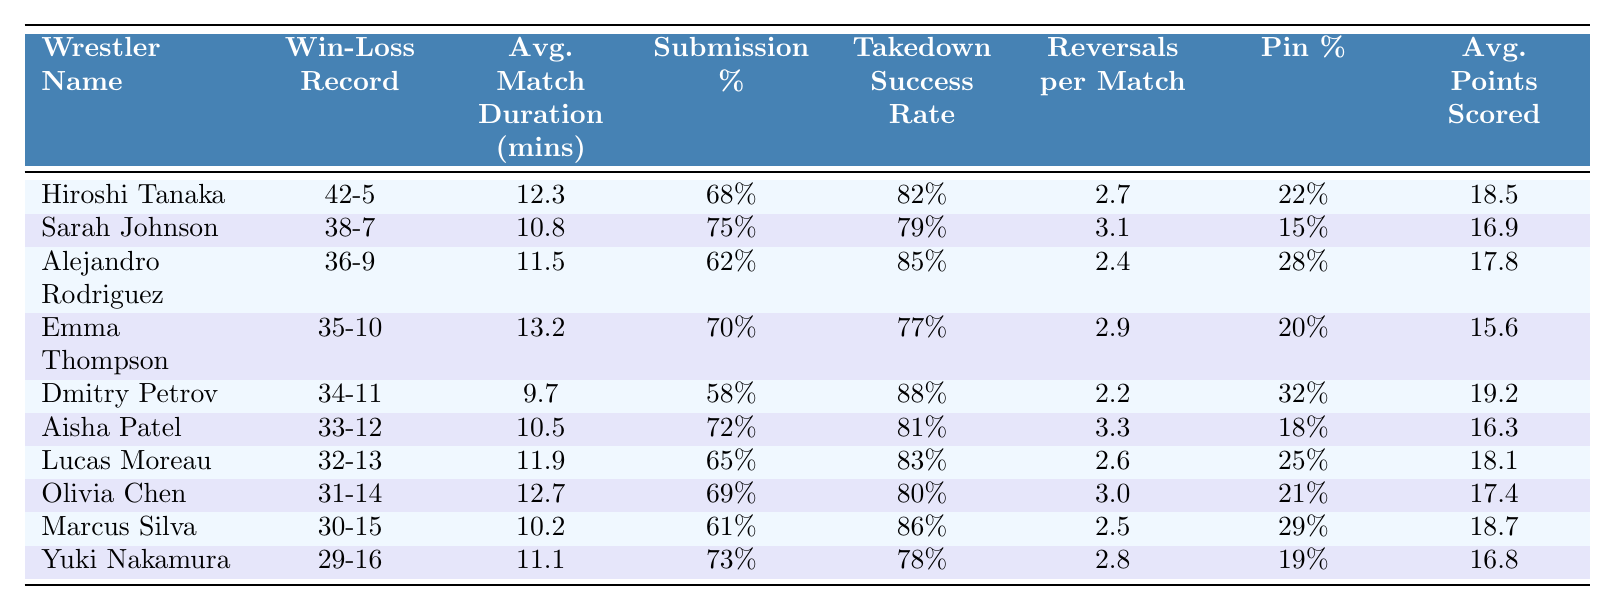What is the win-loss record of Hiroshi Tanaka? The table shows that Hiroshi Tanaka has a win-loss record listed directly under his name, which is 42-5.
Answer: 42-5 Which wrestler has the highest submission percentage? By comparing the submission percentages in the table, Sarah Johnson has the highest percentage at 75%.
Answer: 75% What is the average match duration for Emma Thompson? Looking directly in the table, the average match duration for Emma Thompson is noted as 13.2 minutes.
Answer: 13.2 minutes Who has the lowest pin percentage among the wrestlers? The pin percentages for each wrestler are listed, with Dmitry Petrov having the lowest at 58%.
Answer: 58% How many wrestlers have an average points scored greater than 17? By going through the average points scored column, we can see that six wrestlers (Hiroshi Tanaka, Alejandro Rodriguez, Dmitry Petrov, Lucas Moreau, Marcus Silva) scored more than 17 points.
Answer: 6 What is the difference in takedown success rate between Dimitry Petrov and Alejandro Rodriguez? The takedown success rate for Dimitry Petrov is 88% and for Alejandro Rodriguez is 85%. The difference is (88 - 85) = 3%.
Answer: 3% True or False: Marcus Silva has a higher takedown success rate than Yuki Nakamura. By comparing the takedown success rates, Marcus Silva is at 86% while Yuki Nakamura is at 78%, confirming that the statement is true.
Answer: True What is the average submission percentage for the top 10 wrestlers? To find the average, sum the submission percentages (68 + 75 + 62 + 70 + 58 + 72 + 65 + 69 + 61 + 73 =  685) and divide by 10, giving an average of 68.5%.
Answer: 68.5% How many reversals per match does Aisha Patel average, and how does this compare with Hiroshi Tanaka's statistics? Aisha Patel averages 3.3 reversals per match while Hiroshi Tanaka averages 2.7. Therefore, Aisha has 0.6 more reversals than Hiroshi.
Answer: 3.3; 0.6 more If Emma Thompson improved her pin percentage by 10%, what would her new pin percentage be? Emma Thompson's current pin percentage is 20%. If she improves it by 10%, her new pin percentage would be (20 + 10) = 30%.
Answer: 30% 